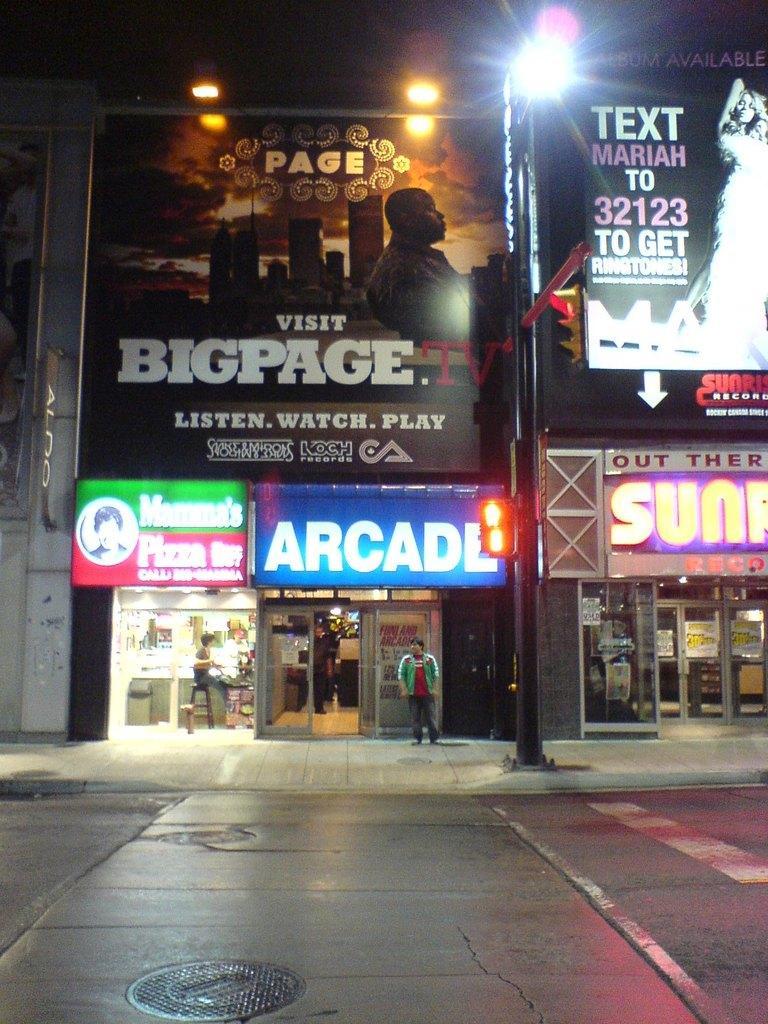How would you summarize this image in a sentence or two? In this picture we can see people and in the background we can see buildings,name boards,lights. 